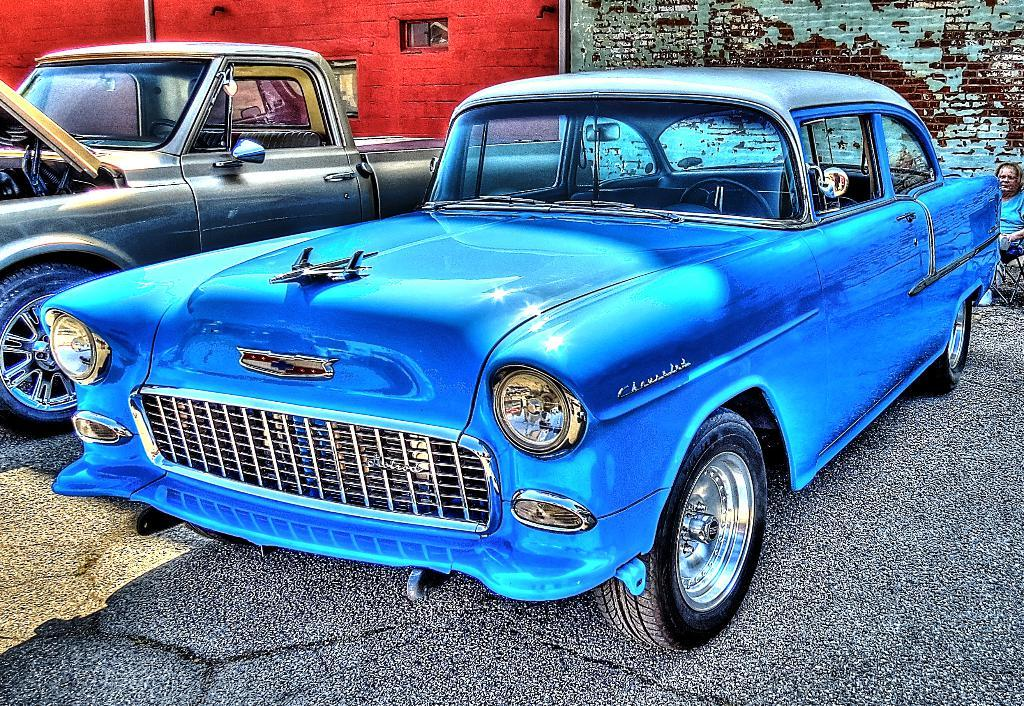What type of vehicles can be seen on the road in the image? There are cars on the road in the image. What can be seen in the background of the image? There is a wall visible in the background of the image. What type of pest is causing damage to the wall in the image? There is no pest visible in the image, and the wall appears undamaged. What tool is being used to hit the cars in the image? There is no tool or person hitting the cars in the image; the cars are simply driving on the road. 